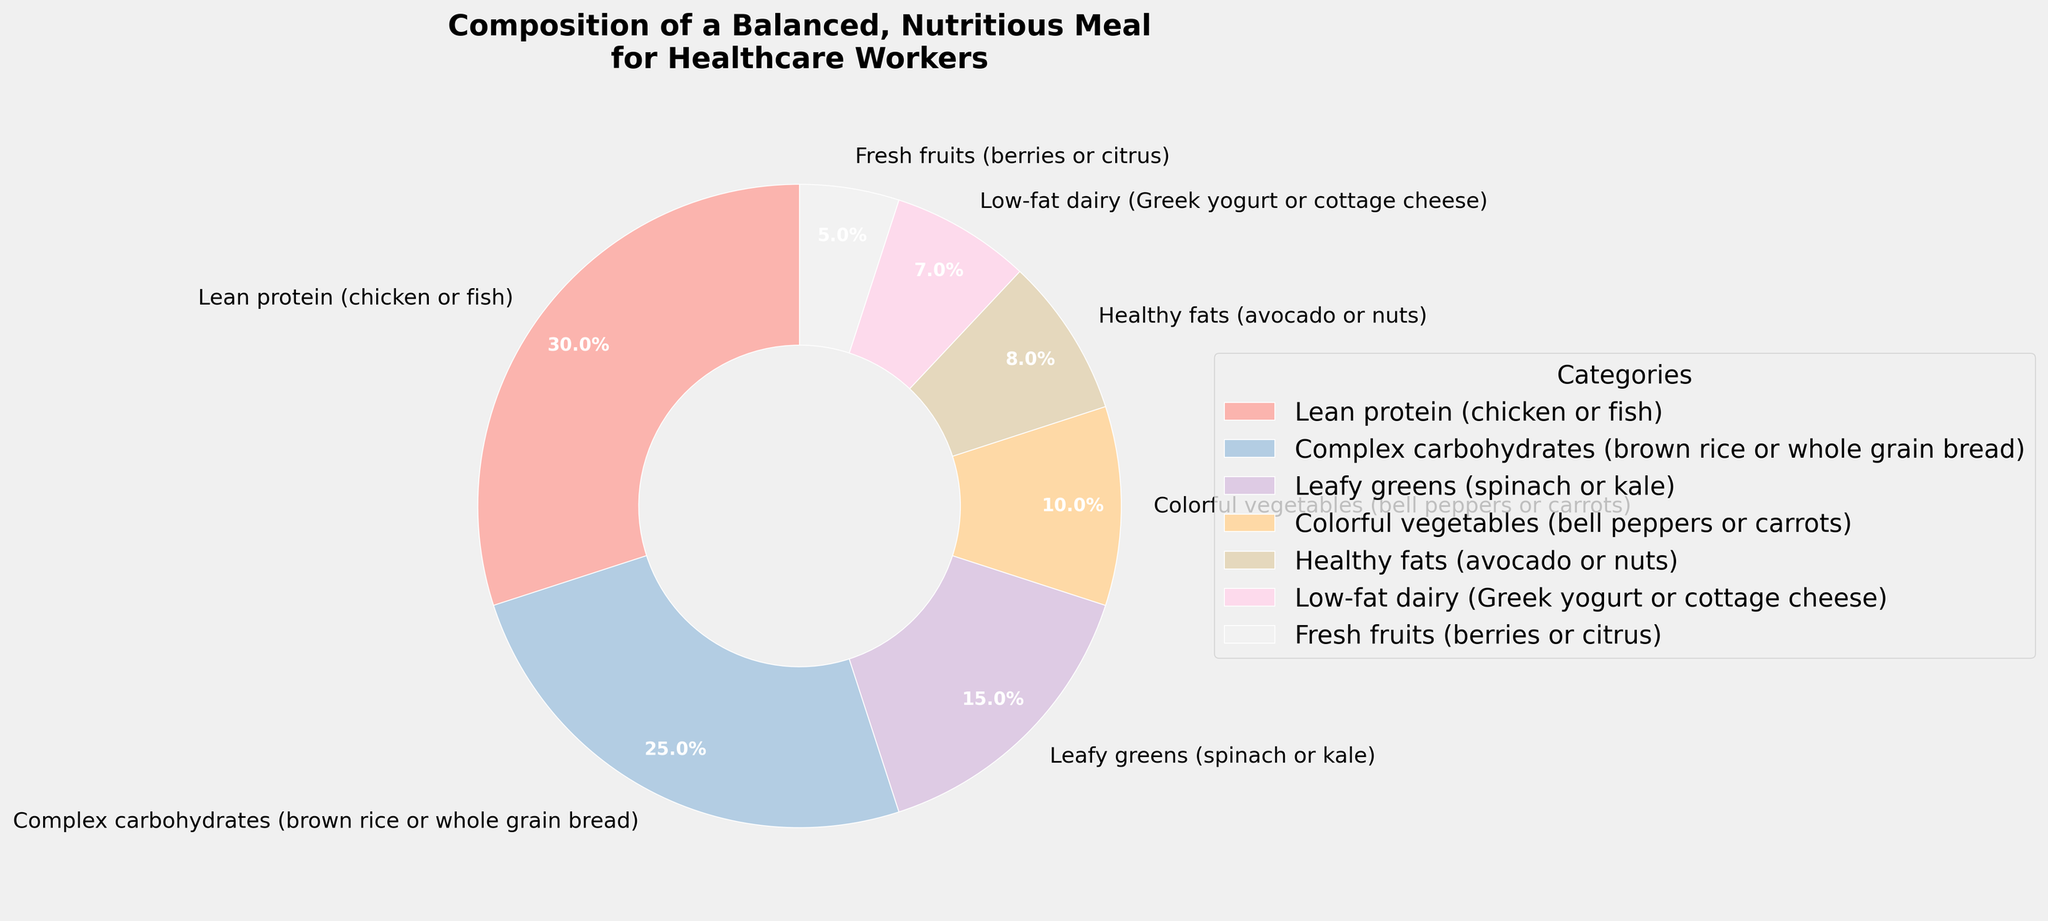What's the total percentage composition of colorful vegetables and healthy fats? Colorful vegetables account for 10% and healthy fats for 8%. Adding these together: 10% + 8% = 18%
Answer: 18% Which category has the highest percentage? By visually inspecting the pie chart, the largest wedge corresponds to lean protein (chicken or fish), which is 30%
Answer: Lean protein (chicken or fish) Are complex carbohydrates greater than fresh fruits? Complex carbohydrates are 25% and fresh fruits are 5%. Since 25% > 5%, complex carbohydrates are indeed greater than fresh fruits.
Answer: Yes How do the percentages for leafy greens and low-fat dairy compare? Leafy greens are at 15% while low-fat dairy is at 7%. Comparatively, leafy greens have a higher percentage.
Answer: Leafy greens have a higher percentage What is the average percentage of the three highest categories? The three highest percentages are: Lean protein (30%), Complex carbohydrates (25%), and Leafy greens (15%). Calculating the average: (30% + 25% + 15%) / 3 = 23.33%
Answer: 23.33% Which category contributes the least to the meal composition? The smallest wedge in the pie chart corresponds to fresh fruits, which is 5%
Answer: Fresh fruits What is the difference in percentage between the highest and lowest categories? The highest category is lean protein (30%) and the lowest is fresh fruits (5%). Subtracting these: 30% - 5% = 25%
Answer: 25% How many categories have a percentage below 10%? Examining the pie chart, the categories below 10% are healthy fats (8%), low-fat dairy (7%), and fresh fruits (5%). This makes it a total of 3 categories
Answer: 3 What is the total percentage composition of leafy greens, colorful vegetables, and fresh fruits? Summing up their percentages: Leafy greens (15%) + Colorful vegetables (10%) + Fresh fruits (5%) = 30%
Answer: 30% Which category has a wedge closest in size to healthy fats? Healthy fats stand at 8%, and the closest is low-fat dairy, which is 7%
Answer: Low-fat dairy 